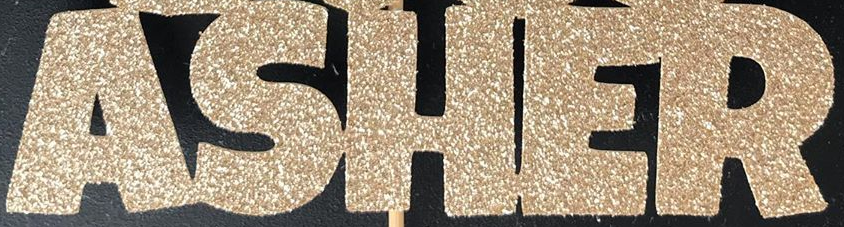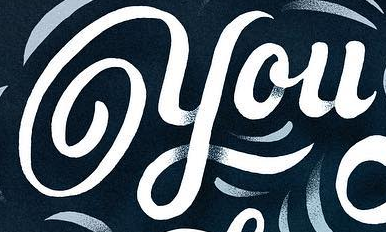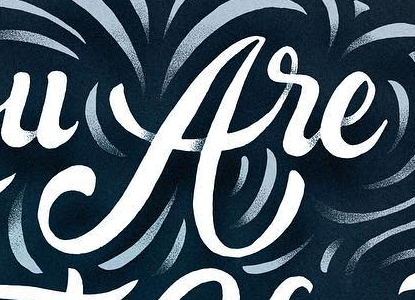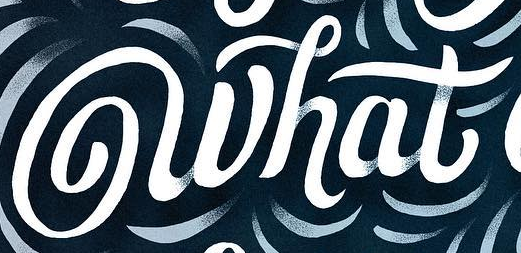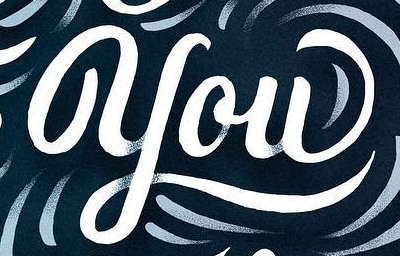Read the text from these images in sequence, separated by a semicolon. ASHER; you; are; what; you 